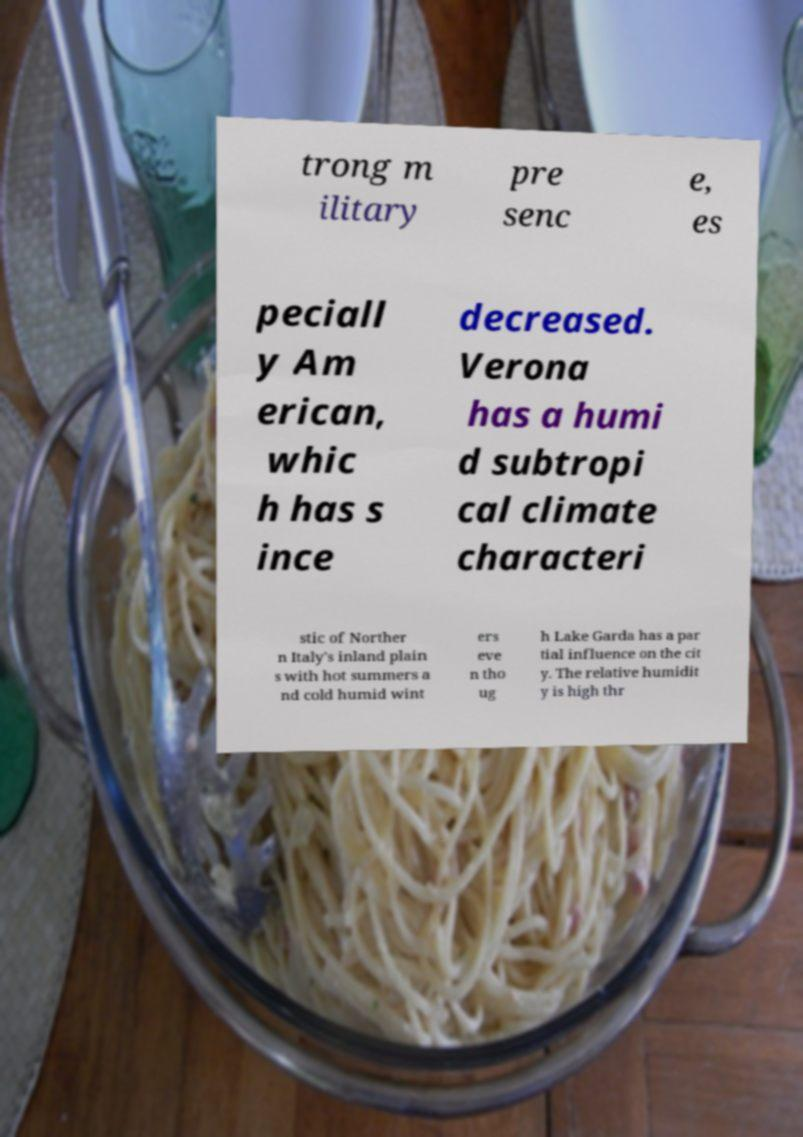What messages or text are displayed in this image? I need them in a readable, typed format. trong m ilitary pre senc e, es peciall y Am erican, whic h has s ince decreased. Verona has a humi d subtropi cal climate characteri stic of Norther n Italy's inland plain s with hot summers a nd cold humid wint ers eve n tho ug h Lake Garda has a par tial influence on the cit y. The relative humidit y is high thr 